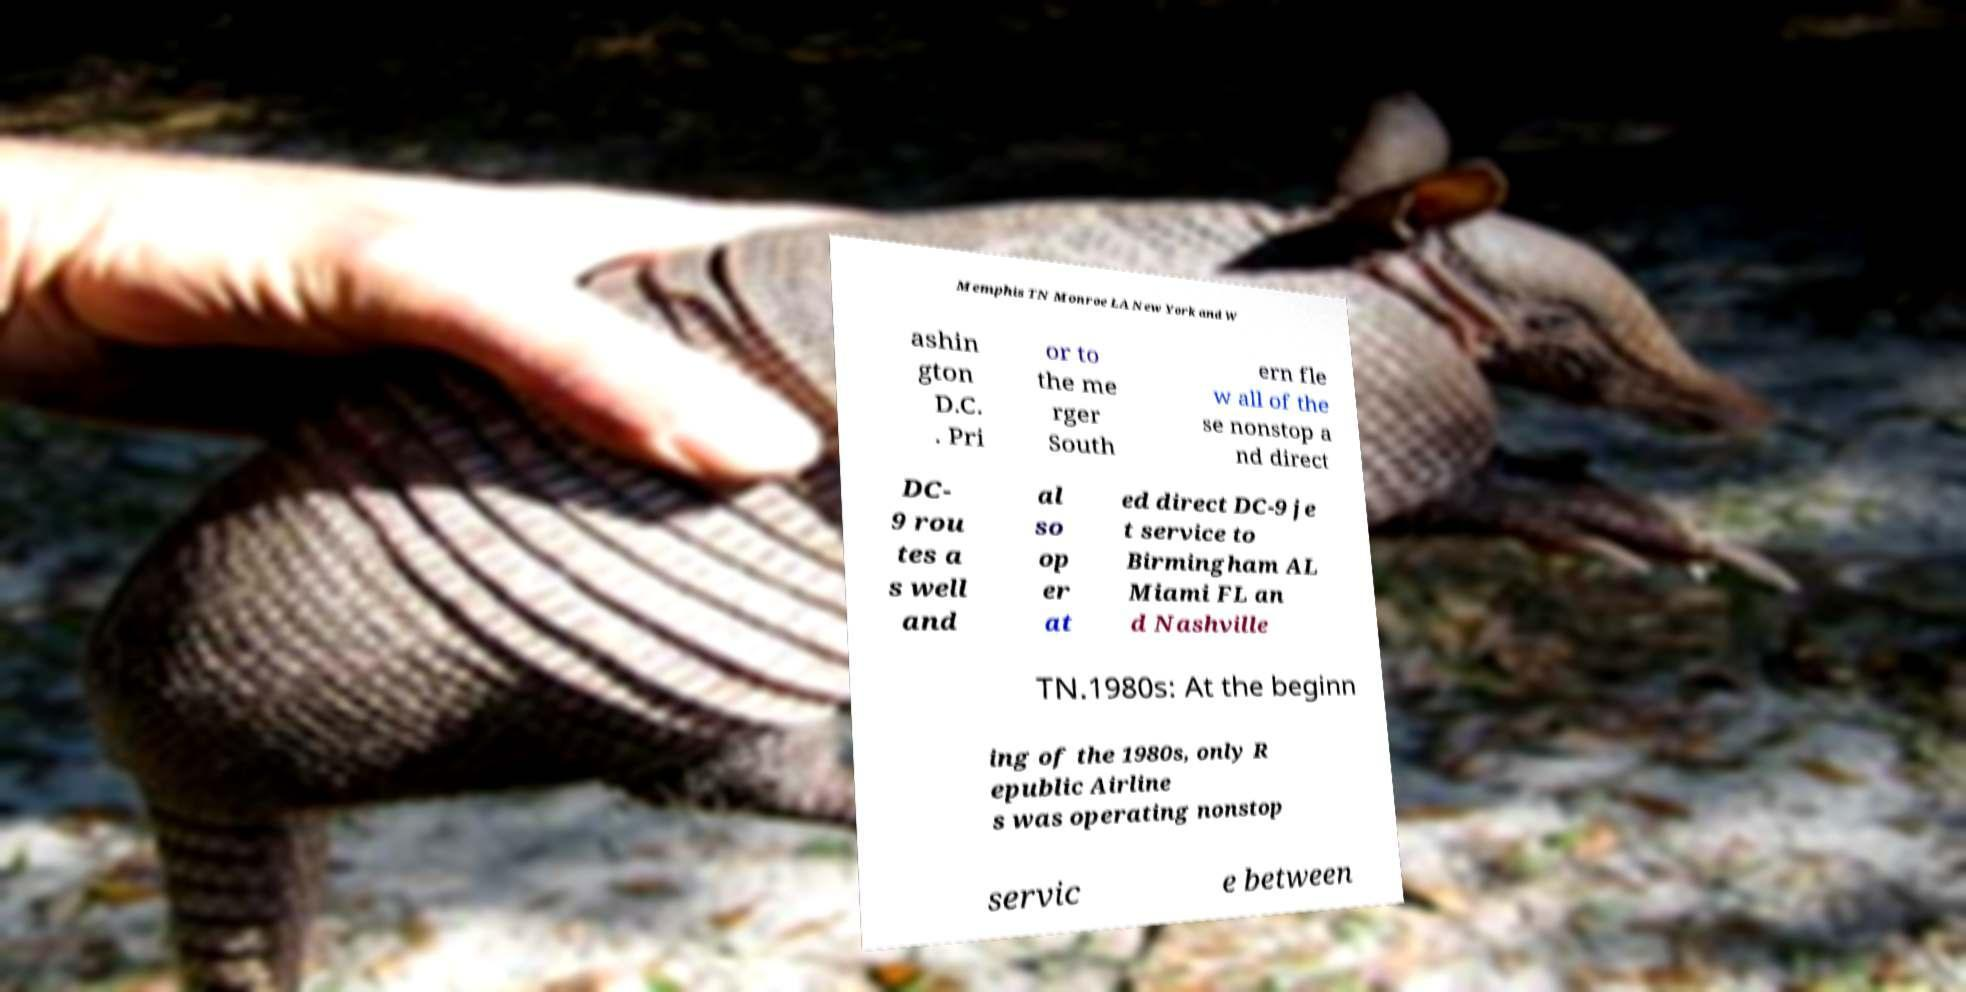Can you accurately transcribe the text from the provided image for me? Memphis TN Monroe LA New York and W ashin gton D.C. . Pri or to the me rger South ern fle w all of the se nonstop a nd direct DC- 9 rou tes a s well and al so op er at ed direct DC-9 je t service to Birmingham AL Miami FL an d Nashville TN.1980s: At the beginn ing of the 1980s, only R epublic Airline s was operating nonstop servic e between 